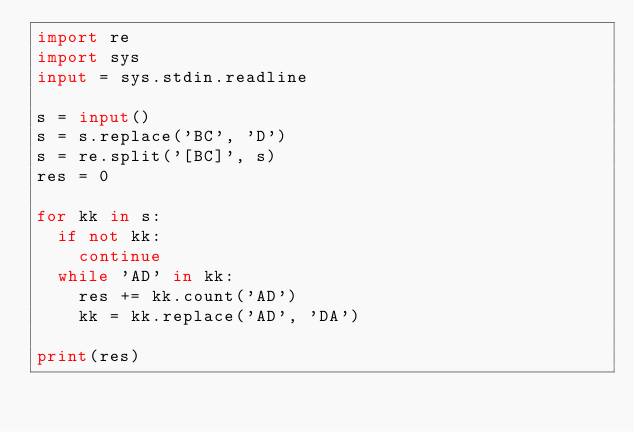Convert code to text. <code><loc_0><loc_0><loc_500><loc_500><_Python_>import re
import sys
input = sys.stdin.readline

s = input()
s = s.replace('BC', 'D')
s = re.split('[BC]', s)
res = 0

for kk in s:
  if not kk:
    continue
  while 'AD' in kk:
    res += kk.count('AD')
    kk = kk.replace('AD', 'DA')
    
print(res)</code> 